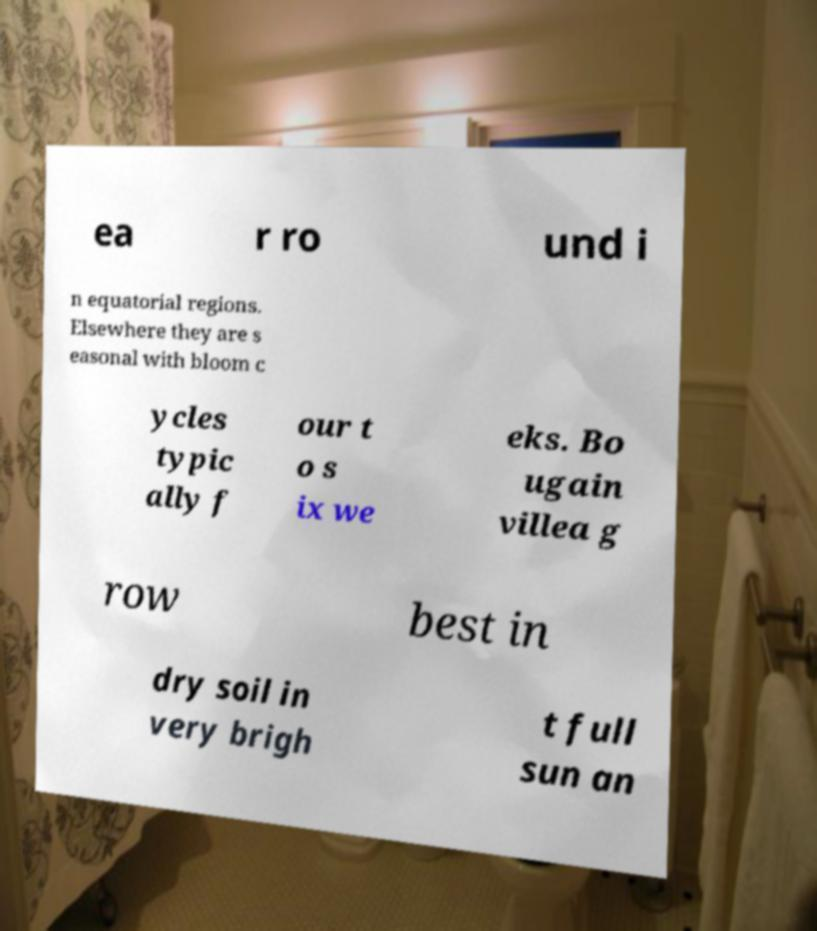Could you extract and type out the text from this image? ea r ro und i n equatorial regions. Elsewhere they are s easonal with bloom c ycles typic ally f our t o s ix we eks. Bo ugain villea g row best in dry soil in very brigh t full sun an 